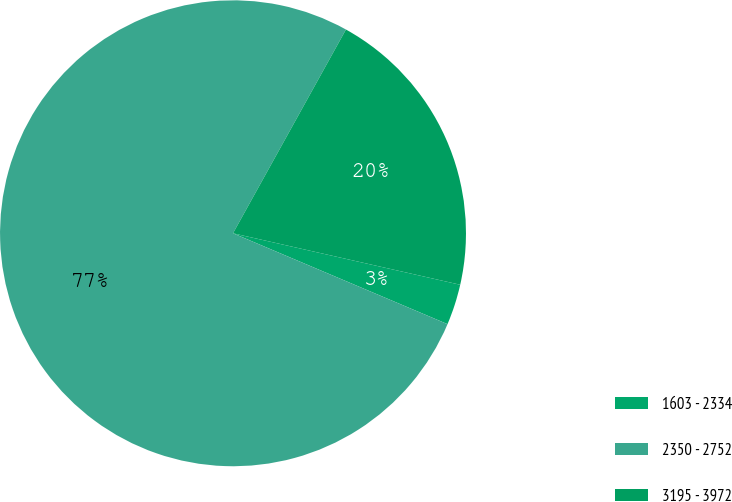Convert chart. <chart><loc_0><loc_0><loc_500><loc_500><pie_chart><fcel>1603 - 2334<fcel>2350 - 2752<fcel>3195 - 3972<nl><fcel>2.83%<fcel>76.68%<fcel>20.49%<nl></chart> 